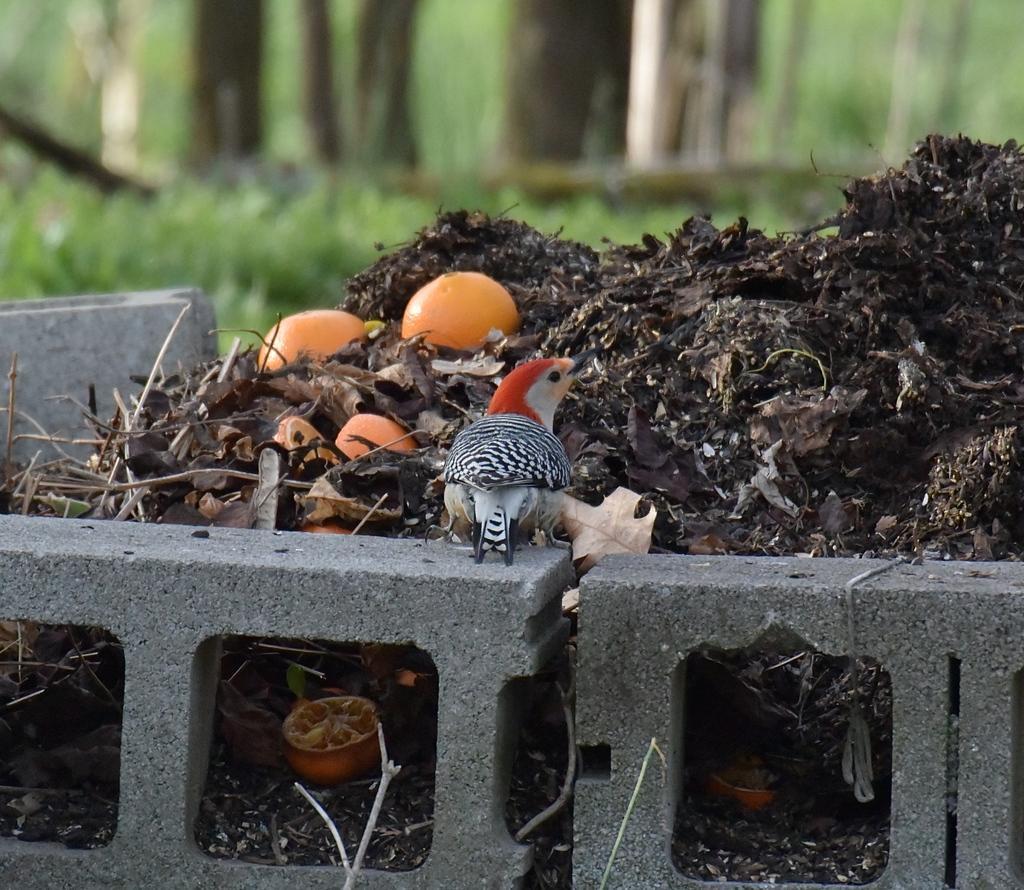In one or two sentences, can you explain what this image depicts? In this image I can see the bird on the road. The bird is in white, black and red color. In-front of the bird I can see oranges in the garbage. And there are trees in the back but it is blurry. 